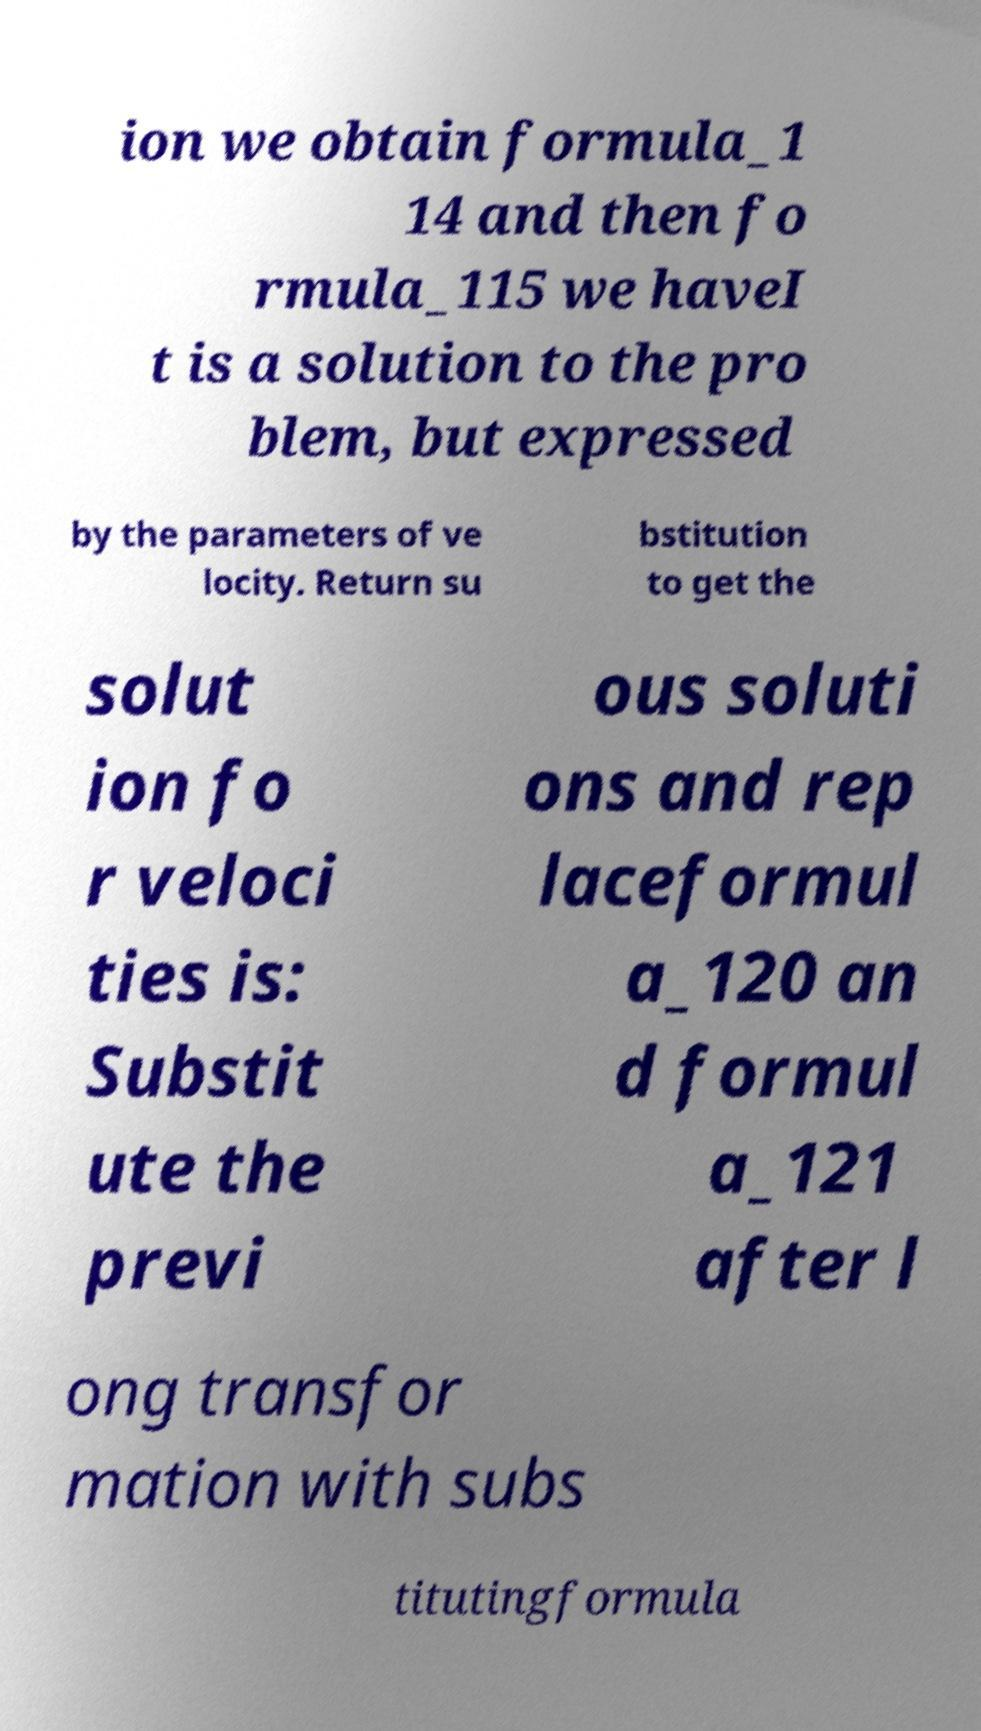I need the written content from this picture converted into text. Can you do that? ion we obtain formula_1 14 and then fo rmula_115 we haveI t is a solution to the pro blem, but expressed by the parameters of ve locity. Return su bstitution to get the solut ion fo r veloci ties is: Substit ute the previ ous soluti ons and rep laceformul a_120 an d formul a_121 after l ong transfor mation with subs titutingformula 